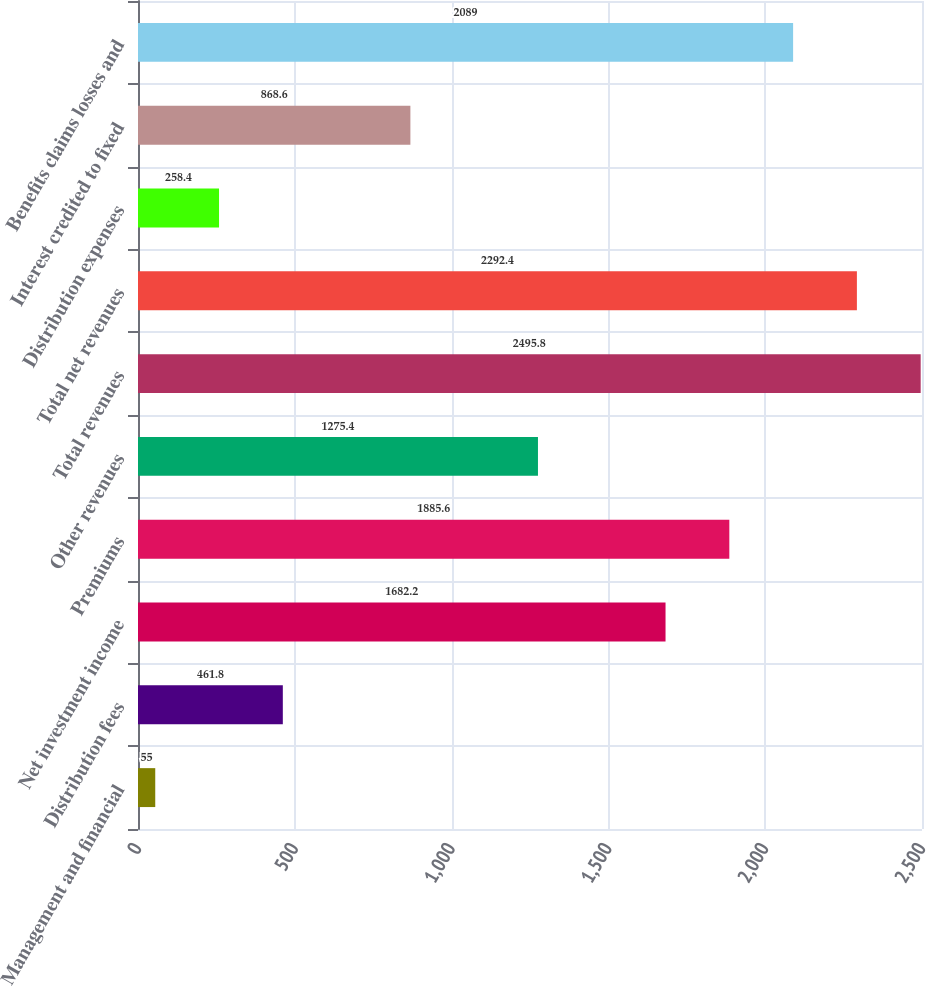Convert chart to OTSL. <chart><loc_0><loc_0><loc_500><loc_500><bar_chart><fcel>Management and financial<fcel>Distribution fees<fcel>Net investment income<fcel>Premiums<fcel>Other revenues<fcel>Total revenues<fcel>Total net revenues<fcel>Distribution expenses<fcel>Interest credited to fixed<fcel>Benefits claims losses and<nl><fcel>55<fcel>461.8<fcel>1682.2<fcel>1885.6<fcel>1275.4<fcel>2495.8<fcel>2292.4<fcel>258.4<fcel>868.6<fcel>2089<nl></chart> 